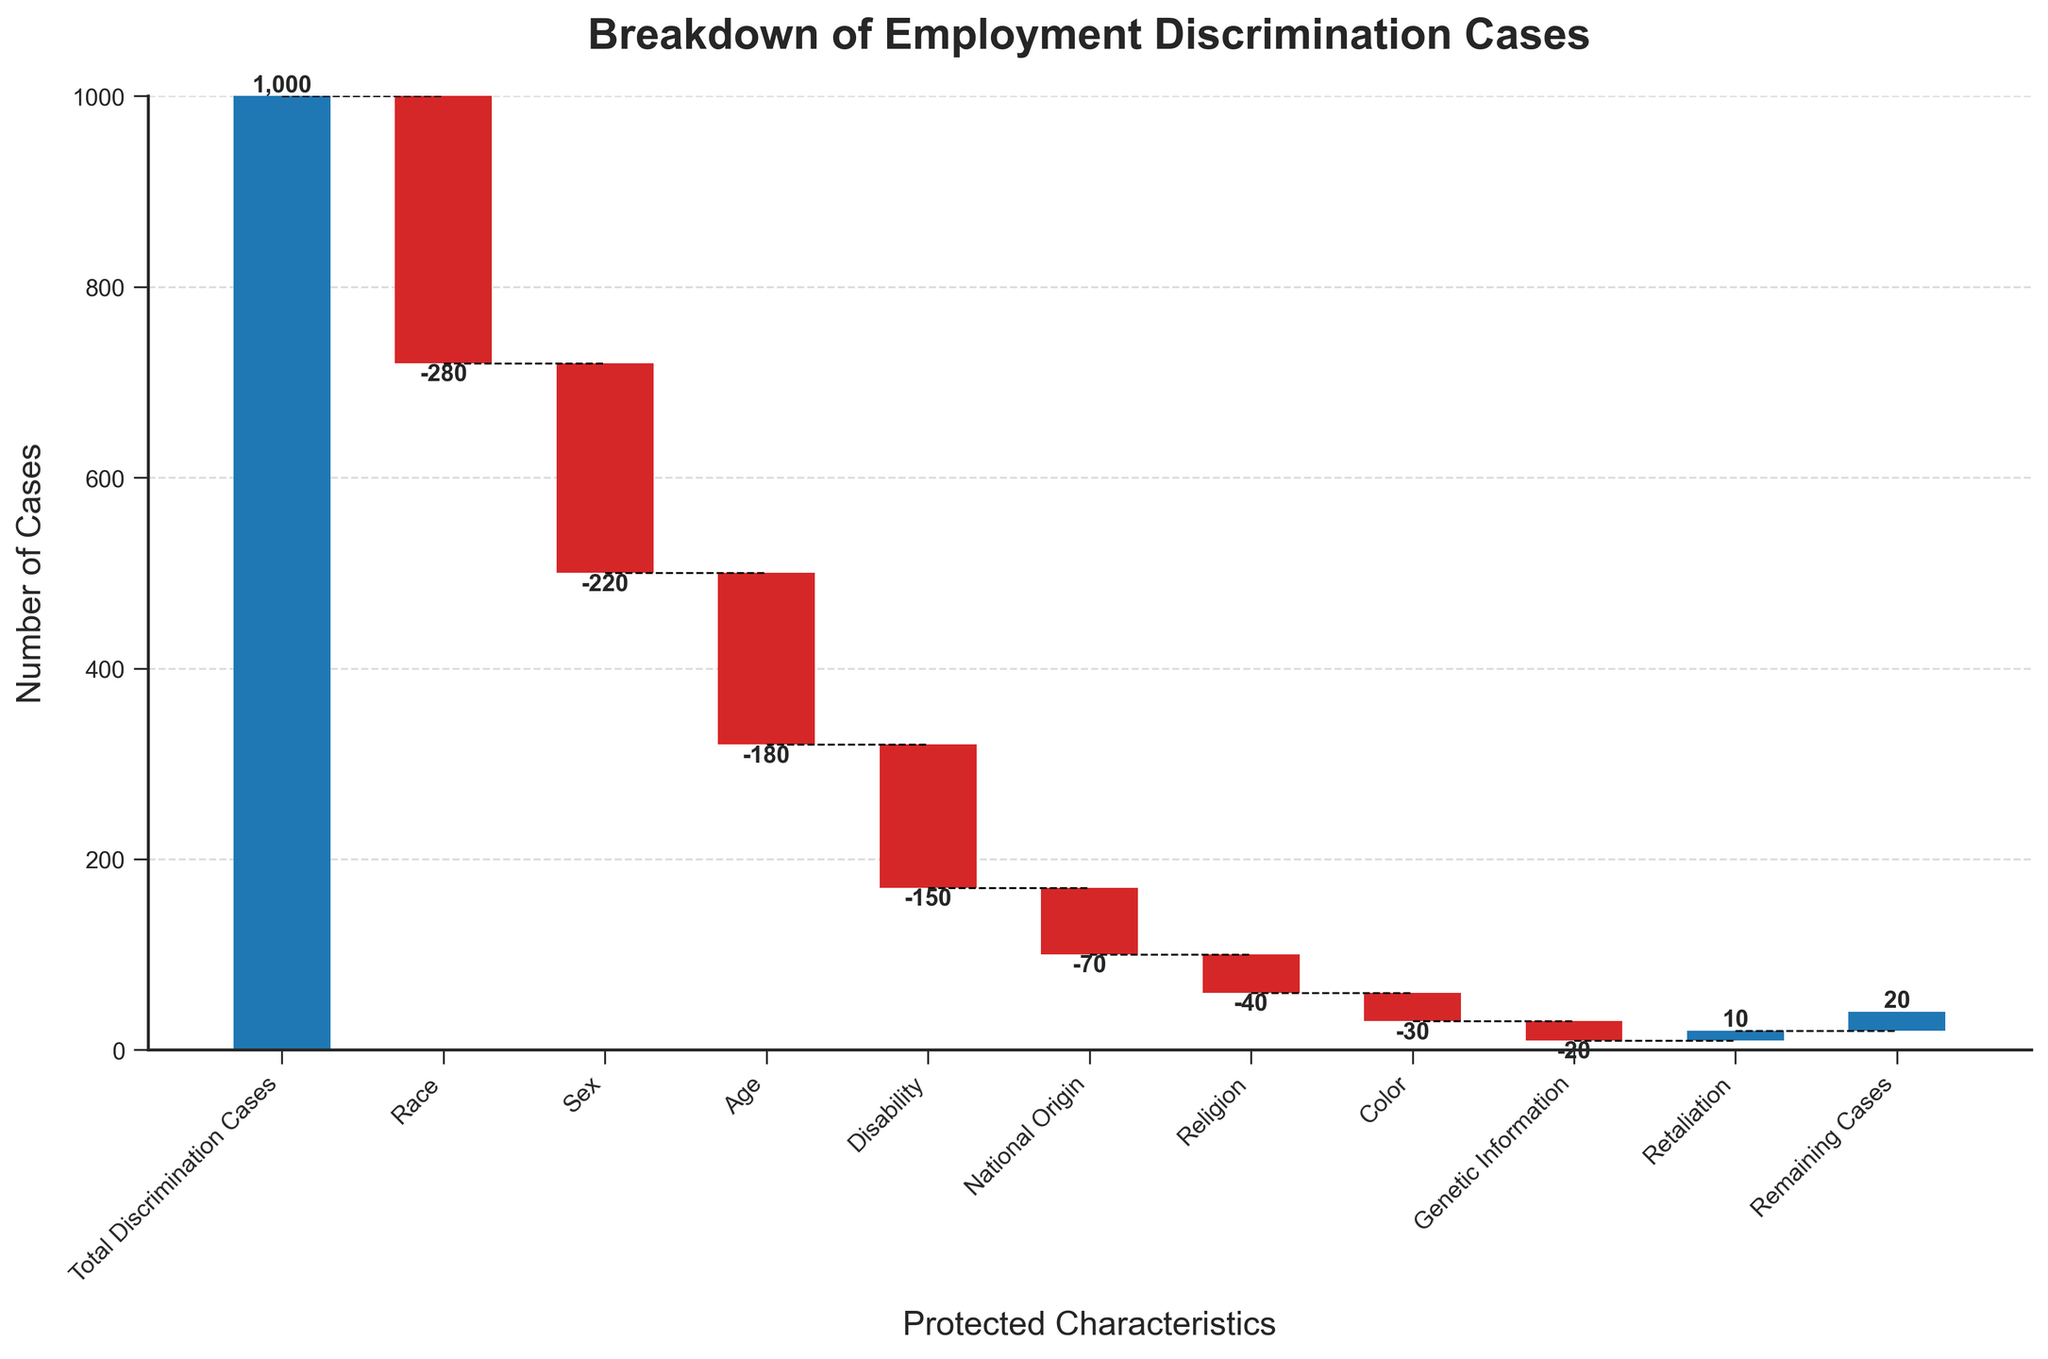What is the title of the chart? The title can be found at the top of the chart, reading "Breakdown of Employment Discrimination Cases".
Answer: Breakdown of Employment Discrimination Cases How many categories of protected characteristics are represented in the chart? Count the number of categories labeled on the x-axis. There are nine protected characteristics plus the total and remaining cases.
Answer: 11 What is the total number of discrimination cases? According to the first bar in the chart, labeled "Total Discrimination Cases", the value is 1000.
Answer: 1000 Which protected characteristic has the greatest number of discrimination cases? Compare the negative values (since this is a waterfall chart) to find the largest magnitude. The "Race" category has the highest number of cases at -280.
Answer: Race How many more discrimination cases are based on race compared to sex? Cross-reference the values for "Race" and "Sex". "Race" has -280 cases, and "Sex" has -220 cases. The difference is 280 - 220 = 60.
Answer: 60 What is the cumulative total of discrimination cases remaining after considering race, sex, and age? Add the values of "Race" (-280), "Sex" (-220), and "Age" (-180): 1000 - 280 - 220 - 180 = 320.
Answer: 320 What is the percentage of cases attributed to national origin out of the initial total? Compute the percentage by dividing the number of cases for national origin (-70) by the total number of cases (1000) and multiply by 100: (-70/1000) * 100 = -7%.
Answer: -7% Which characteristic has the least number of reported cases? Look for the smallest negative value on the chart. "Genetic Information" has the least number of reported cases at -20.
Answer: Genetic Information How does the number of cases attributed to retaliation compare to those attributed to disability? "Retaliation" has 10 cases while "Disability" has -150 cases. Retaliation has more cases as it is a positive number in comparison to the others being negative.
Answer: Retaliation is greater What is the total number of cases after all reductions and additions are accounted for? The final bar labeled "Remaining Cases" shows the total which is the sum of all previous values. It is 20.
Answer: 20 